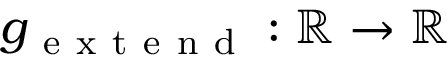Convert formula to latex. <formula><loc_0><loc_0><loc_500><loc_500>g _ { e x t e n d } \colon \mathbb { R } \to \mathbb { R }</formula> 